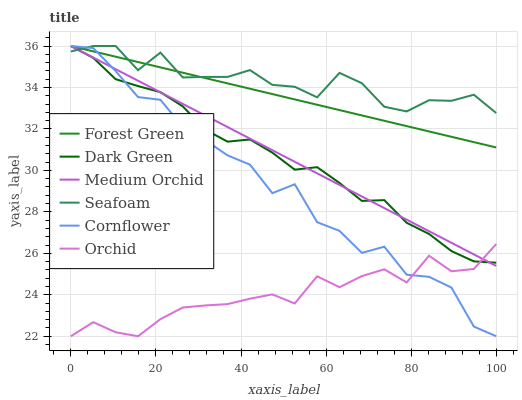Does Orchid have the minimum area under the curve?
Answer yes or no. Yes. Does Seafoam have the maximum area under the curve?
Answer yes or no. Yes. Does Medium Orchid have the minimum area under the curve?
Answer yes or no. No. Does Medium Orchid have the maximum area under the curve?
Answer yes or no. No. Is Medium Orchid the smoothest?
Answer yes or no. Yes. Is Cornflower the roughest?
Answer yes or no. Yes. Is Seafoam the smoothest?
Answer yes or no. No. Is Seafoam the roughest?
Answer yes or no. No. Does Cornflower have the lowest value?
Answer yes or no. Yes. Does Medium Orchid have the lowest value?
Answer yes or no. No. Does Dark Green have the highest value?
Answer yes or no. Yes. Does Orchid have the highest value?
Answer yes or no. No. Is Orchid less than Forest Green?
Answer yes or no. Yes. Is Forest Green greater than Orchid?
Answer yes or no. Yes. Does Medium Orchid intersect Dark Green?
Answer yes or no. Yes. Is Medium Orchid less than Dark Green?
Answer yes or no. No. Is Medium Orchid greater than Dark Green?
Answer yes or no. No. Does Orchid intersect Forest Green?
Answer yes or no. No. 